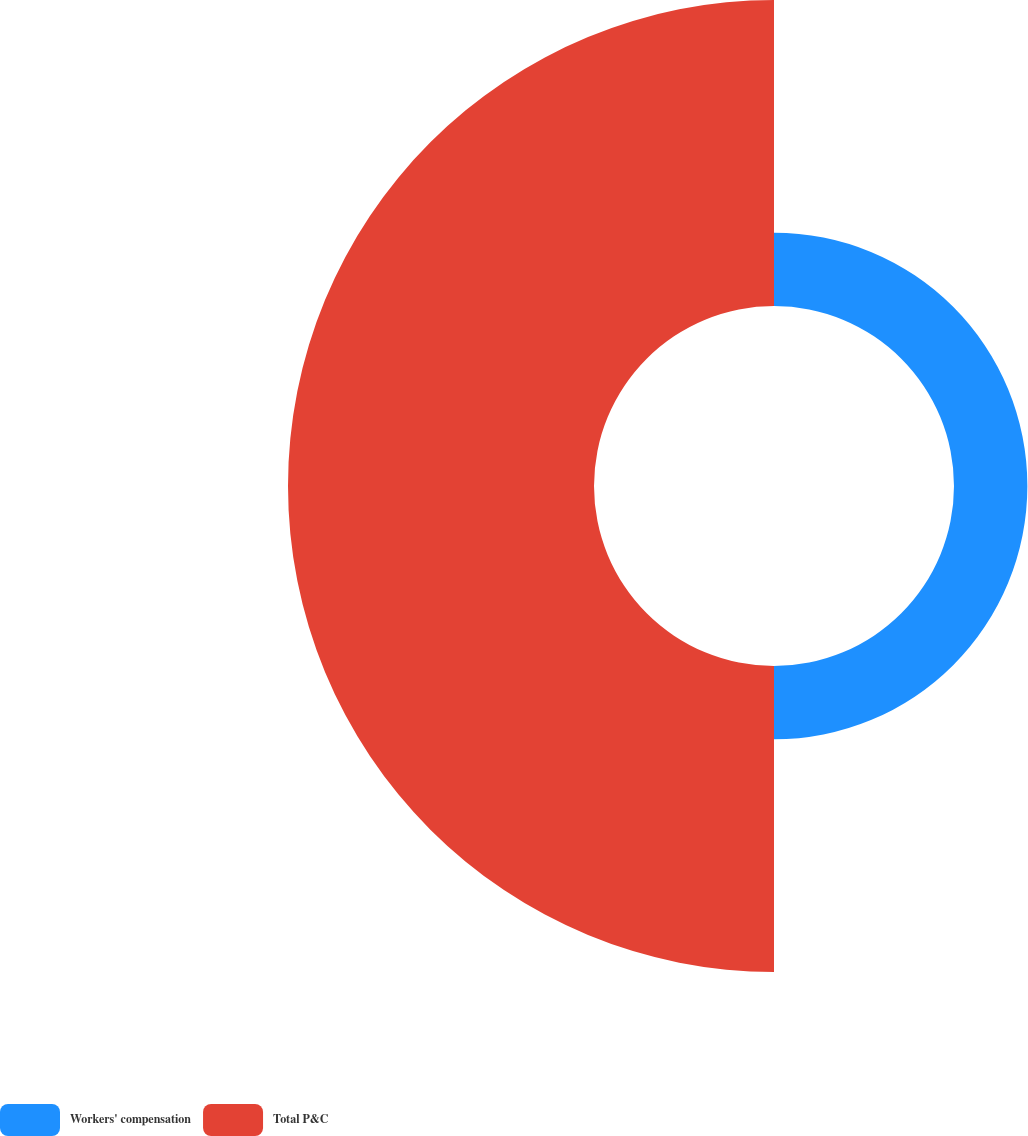Convert chart to OTSL. <chart><loc_0><loc_0><loc_500><loc_500><pie_chart><fcel>Workers' compensation<fcel>Total P&C<nl><fcel>19.34%<fcel>80.66%<nl></chart> 